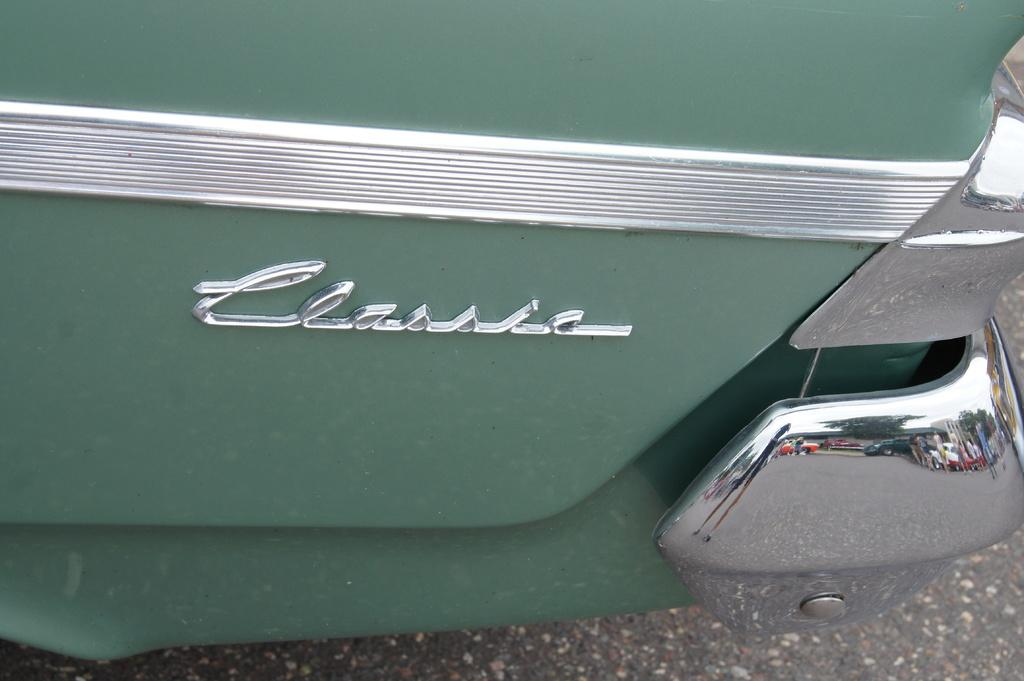What is the main subject of the image? There is a vehicle in the image. Where is the vehicle located? The vehicle is on the road. Is there any identifying mark or symbol on the vehicle? Yes, there is a logo on the vehicle. How many hooks can be seen hanging from the vehicle in the image? There are no hooks visible in the image; the main subject is a vehicle with a logo on it. 